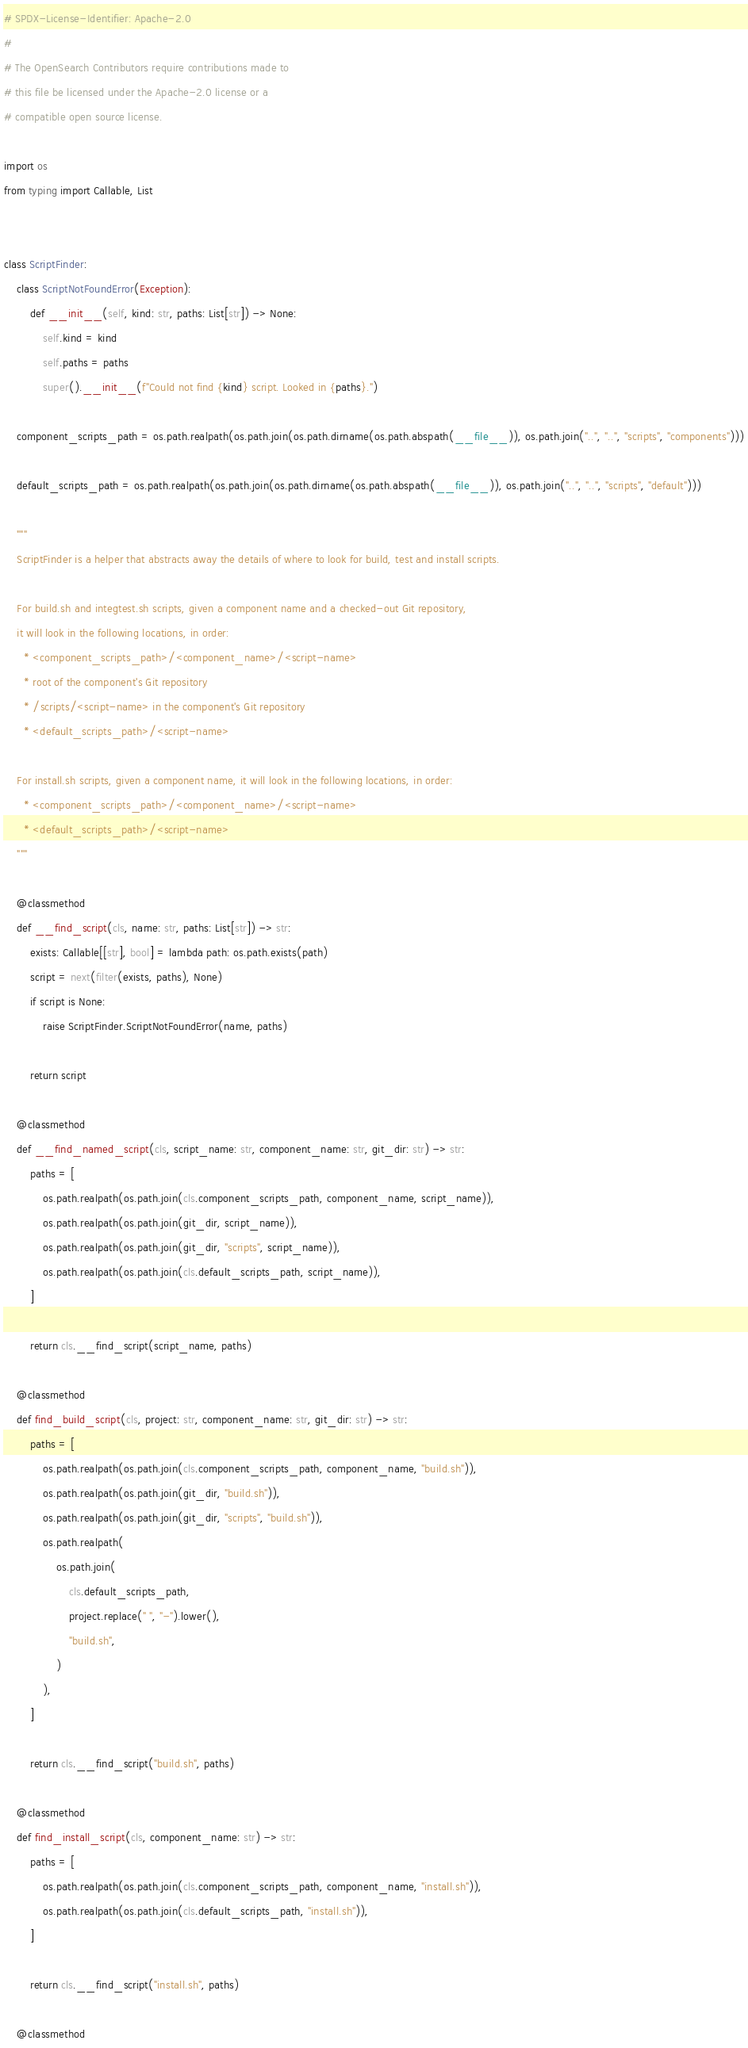Convert code to text. <code><loc_0><loc_0><loc_500><loc_500><_Python_># SPDX-License-Identifier: Apache-2.0
#
# The OpenSearch Contributors require contributions made to
# this file be licensed under the Apache-2.0 license or a
# compatible open source license.

import os
from typing import Callable, List


class ScriptFinder:
    class ScriptNotFoundError(Exception):
        def __init__(self, kind: str, paths: List[str]) -> None:
            self.kind = kind
            self.paths = paths
            super().__init__(f"Could not find {kind} script. Looked in {paths}.")

    component_scripts_path = os.path.realpath(os.path.join(os.path.dirname(os.path.abspath(__file__)), os.path.join("..", "..", "scripts", "components")))

    default_scripts_path = os.path.realpath(os.path.join(os.path.dirname(os.path.abspath(__file__)), os.path.join("..", "..", "scripts", "default")))

    """
    ScriptFinder is a helper that abstracts away the details of where to look for build, test and install scripts.

    For build.sh and integtest.sh scripts, given a component name and a checked-out Git repository,
    it will look in the following locations, in order:
      * <component_scripts_path>/<component_name>/<script-name>
      * root of the component's Git repository
      * /scripts/<script-name> in the component's Git repository
      * <default_scripts_path>/<script-name>

    For install.sh scripts, given a component name, it will look in the following locations, in order:
      * <component_scripts_path>/<component_name>/<script-name>
      * <default_scripts_path>/<script-name>
    """

    @classmethod
    def __find_script(cls, name: str, paths: List[str]) -> str:
        exists: Callable[[str], bool] = lambda path: os.path.exists(path)
        script = next(filter(exists, paths), None)
        if script is None:
            raise ScriptFinder.ScriptNotFoundError(name, paths)

        return script

    @classmethod
    def __find_named_script(cls, script_name: str, component_name: str, git_dir: str) -> str:
        paths = [
            os.path.realpath(os.path.join(cls.component_scripts_path, component_name, script_name)),
            os.path.realpath(os.path.join(git_dir, script_name)),
            os.path.realpath(os.path.join(git_dir, "scripts", script_name)),
            os.path.realpath(os.path.join(cls.default_scripts_path, script_name)),
        ]

        return cls.__find_script(script_name, paths)

    @classmethod
    def find_build_script(cls, project: str, component_name: str, git_dir: str) -> str:
        paths = [
            os.path.realpath(os.path.join(cls.component_scripts_path, component_name, "build.sh")),
            os.path.realpath(os.path.join(git_dir, "build.sh")),
            os.path.realpath(os.path.join(git_dir, "scripts", "build.sh")),
            os.path.realpath(
                os.path.join(
                    cls.default_scripts_path,
                    project.replace(" ", "-").lower(),
                    "build.sh",
                )
            ),
        ]

        return cls.__find_script("build.sh", paths)

    @classmethod
    def find_install_script(cls, component_name: str) -> str:
        paths = [
            os.path.realpath(os.path.join(cls.component_scripts_path, component_name, "install.sh")),
            os.path.realpath(os.path.join(cls.default_scripts_path, "install.sh")),
        ]

        return cls.__find_script("install.sh", paths)

    @classmethod</code> 